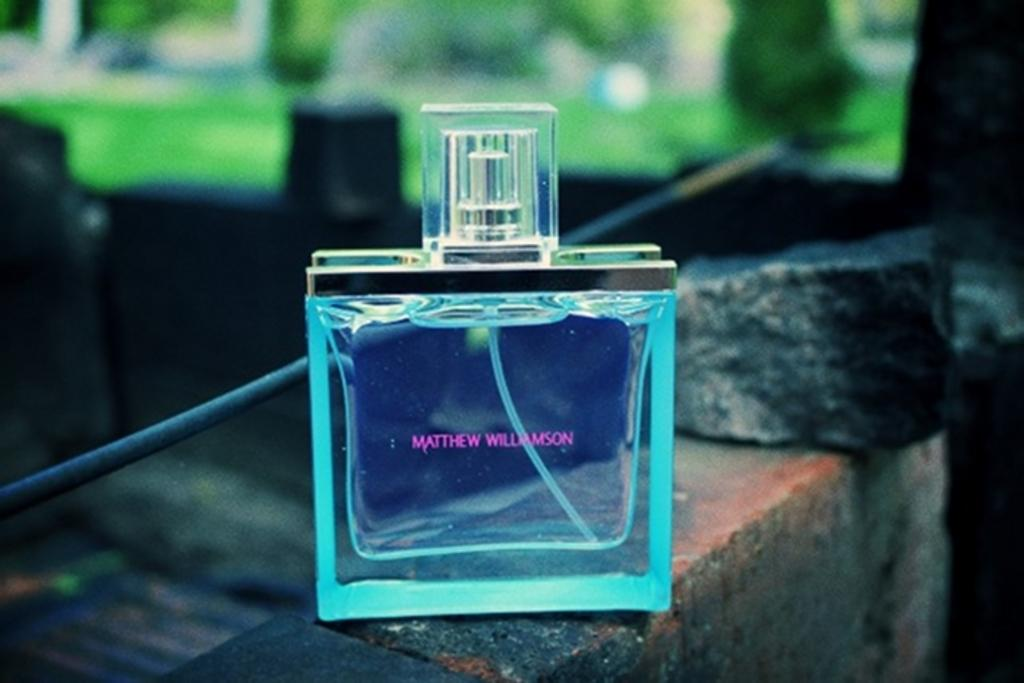<image>
Offer a succinct explanation of the picture presented. A glass cologne/perfume bottle has "Matthew Williamson in purple. 